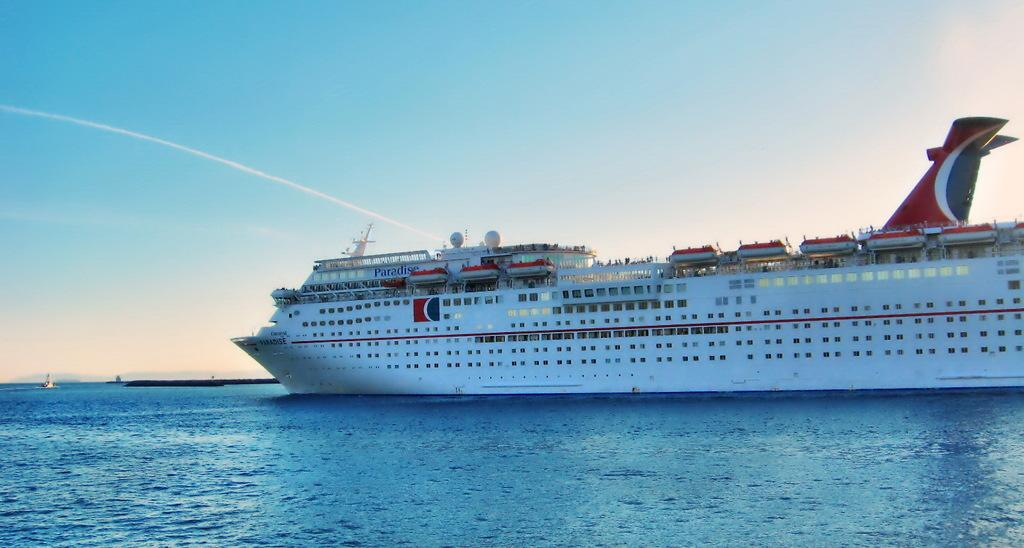<image>
Present a compact description of the photo's key features. A cruise ship on the water that is from Carnival brand called PARADISE. 